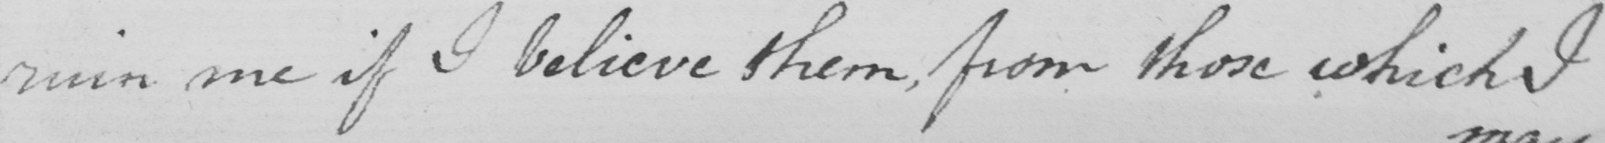What is written in this line of handwriting? ruin me if I believe them , for those which I 